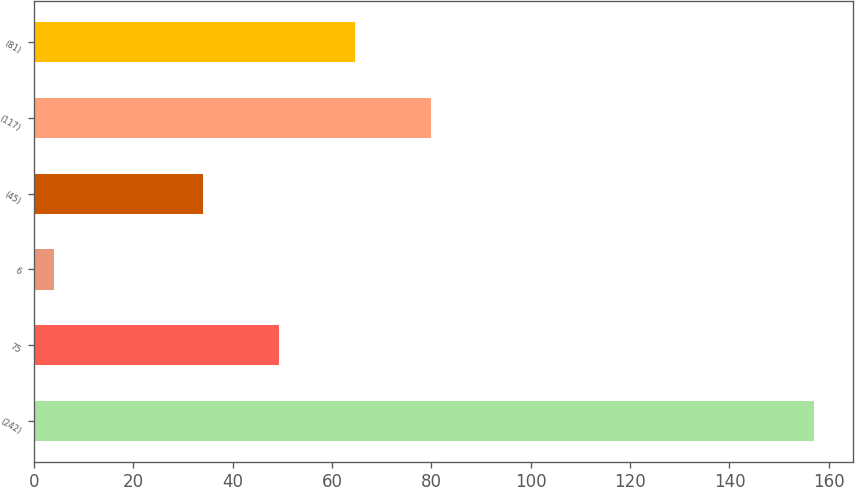Convert chart to OTSL. <chart><loc_0><loc_0><loc_500><loc_500><bar_chart><fcel>(242)<fcel>75<fcel>6<fcel>(45)<fcel>(117)<fcel>(81)<nl><fcel>157<fcel>49.3<fcel>4<fcel>34<fcel>79.9<fcel>64.6<nl></chart> 